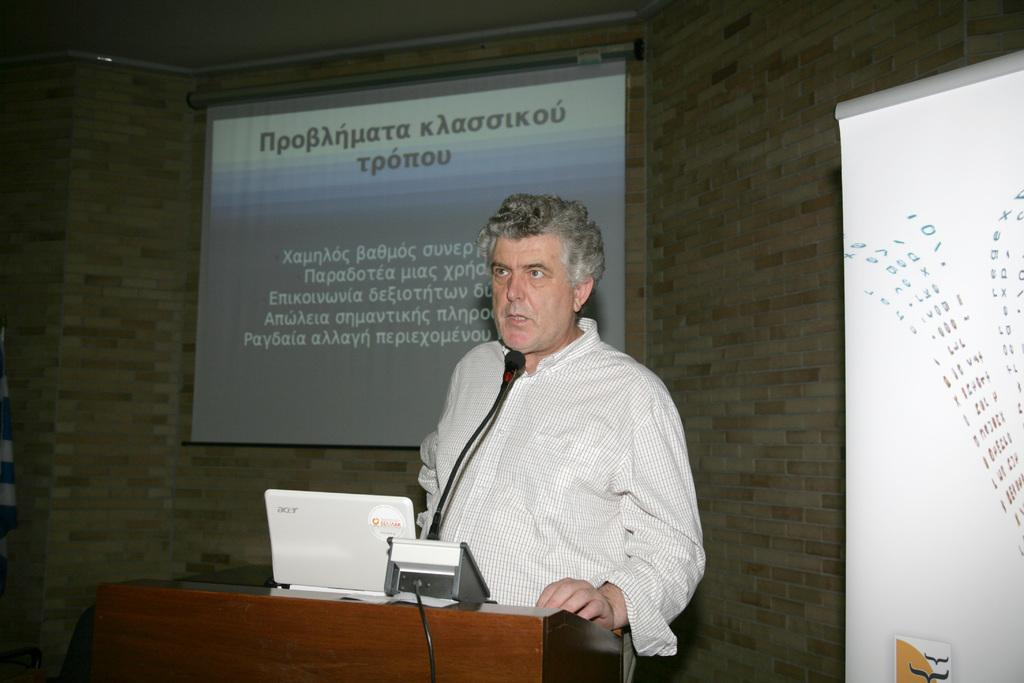What is the man in the image doing? The man is standing in front of a podium. What is on the podium? The podium has a laptop, a microphone, and wires on it. What can be seen in the background of the image? There is a screen, a wall, a board, and a light in the background of the image. What type of stamp is on the man's forehead in the image? There is no stamp on the man's forehead in the image. 